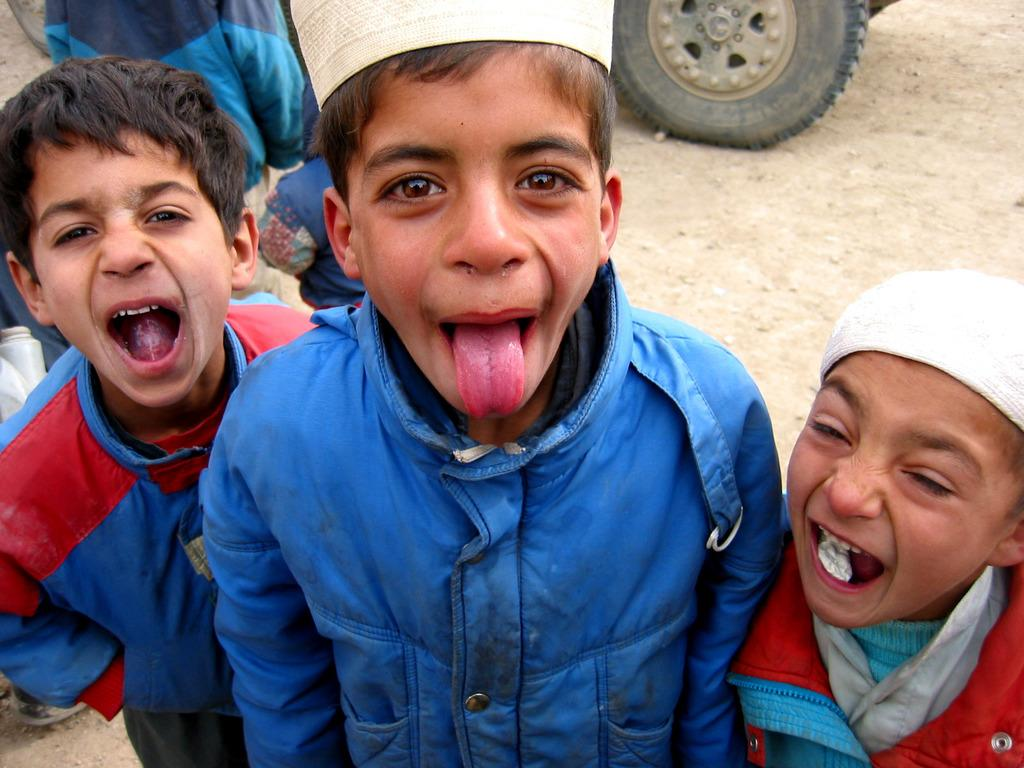Who is present in the image? There are boys in the image. What can be seen in the background of the image? There is a tire in the background of the image. What type of surface is visible at the bottom of the image? There is ground visible at the bottom of the image. How many frogs can be seen jumping in the image? There are no frogs present in the image. What type of wave can be seen crashing on the shore in the image? There is no wave or shore present in the image. 